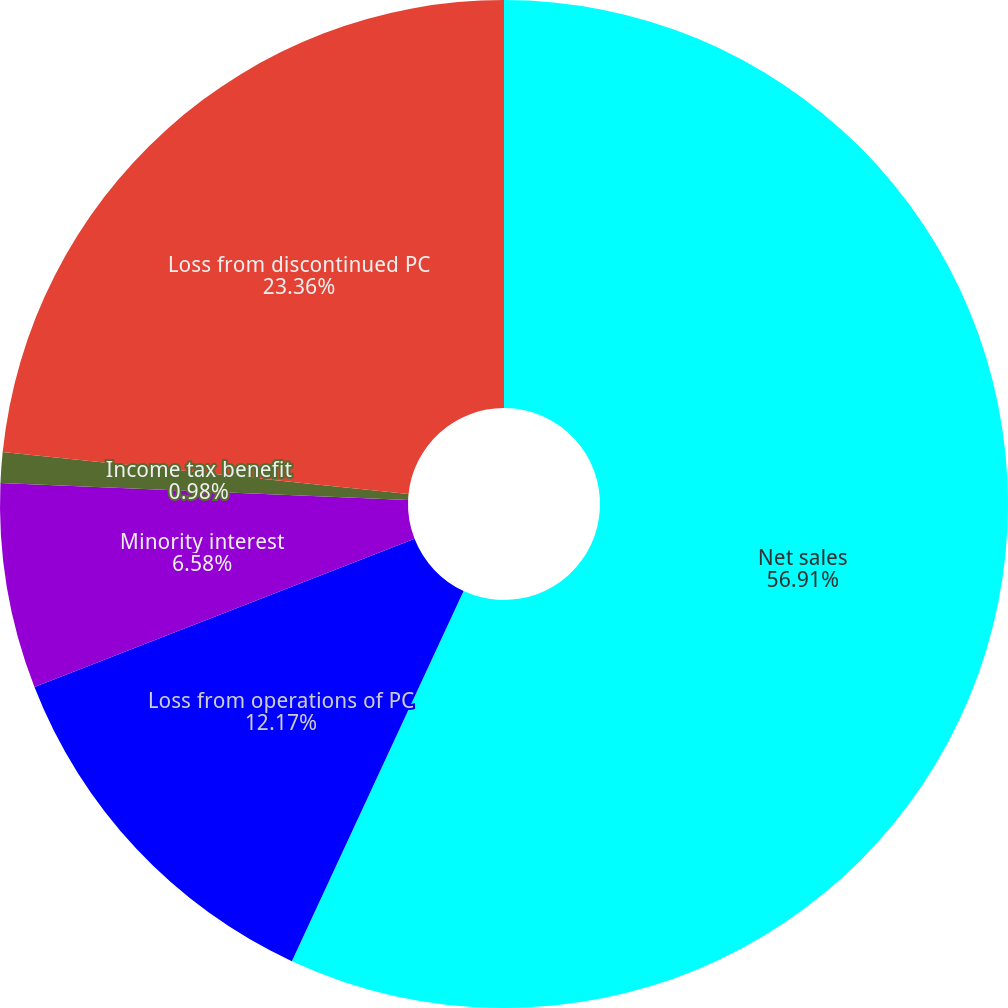<chart> <loc_0><loc_0><loc_500><loc_500><pie_chart><fcel>Net sales<fcel>Loss from operations of PC<fcel>Minority interest<fcel>Income tax benefit<fcel>Loss from discontinued PC<nl><fcel>56.92%<fcel>12.17%<fcel>6.58%<fcel>0.98%<fcel>23.36%<nl></chart> 